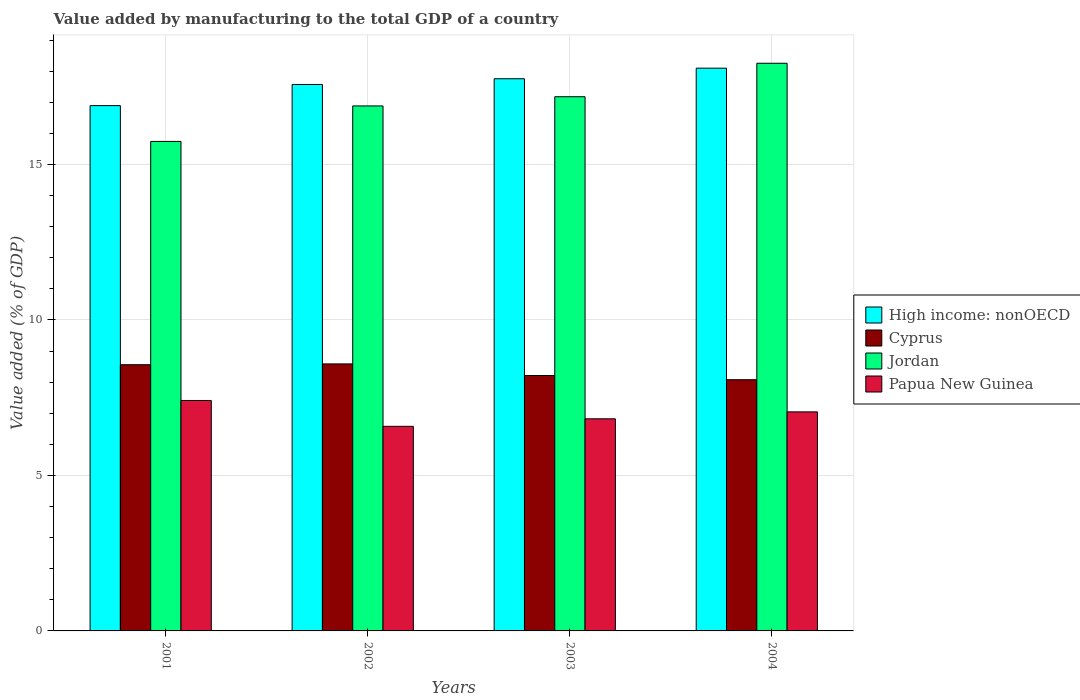How many groups of bars are there?
Your answer should be very brief. 4. Are the number of bars per tick equal to the number of legend labels?
Give a very brief answer. Yes. Are the number of bars on each tick of the X-axis equal?
Ensure brevity in your answer.  Yes. How many bars are there on the 4th tick from the left?
Provide a succinct answer. 4. How many bars are there on the 2nd tick from the right?
Your response must be concise. 4. What is the label of the 2nd group of bars from the left?
Your answer should be compact. 2002. What is the value added by manufacturing to the total GDP in Jordan in 2004?
Your answer should be very brief. 18.26. Across all years, what is the maximum value added by manufacturing to the total GDP in Cyprus?
Keep it short and to the point. 8.59. Across all years, what is the minimum value added by manufacturing to the total GDP in High income: nonOECD?
Your answer should be very brief. 16.9. In which year was the value added by manufacturing to the total GDP in High income: nonOECD maximum?
Offer a very short reply. 2004. In which year was the value added by manufacturing to the total GDP in Jordan minimum?
Provide a succinct answer. 2001. What is the total value added by manufacturing to the total GDP in Papua New Guinea in the graph?
Your answer should be very brief. 27.86. What is the difference between the value added by manufacturing to the total GDP in Papua New Guinea in 2002 and that in 2004?
Make the answer very short. -0.47. What is the difference between the value added by manufacturing to the total GDP in Papua New Guinea in 2001 and the value added by manufacturing to the total GDP in Jordan in 2002?
Make the answer very short. -9.47. What is the average value added by manufacturing to the total GDP in Jordan per year?
Provide a succinct answer. 17.02. In the year 2003, what is the difference between the value added by manufacturing to the total GDP in Papua New Guinea and value added by manufacturing to the total GDP in Jordan?
Your response must be concise. -10.36. What is the ratio of the value added by manufacturing to the total GDP in High income: nonOECD in 2001 to that in 2003?
Your answer should be compact. 0.95. Is the value added by manufacturing to the total GDP in High income: nonOECD in 2002 less than that in 2004?
Ensure brevity in your answer.  Yes. Is the difference between the value added by manufacturing to the total GDP in Papua New Guinea in 2002 and 2003 greater than the difference between the value added by manufacturing to the total GDP in Jordan in 2002 and 2003?
Provide a succinct answer. Yes. What is the difference between the highest and the second highest value added by manufacturing to the total GDP in Jordan?
Offer a very short reply. 1.08. What is the difference between the highest and the lowest value added by manufacturing to the total GDP in Papua New Guinea?
Make the answer very short. 0.83. Is the sum of the value added by manufacturing to the total GDP in Cyprus in 2002 and 2003 greater than the maximum value added by manufacturing to the total GDP in Papua New Guinea across all years?
Keep it short and to the point. Yes. What does the 1st bar from the left in 2004 represents?
Make the answer very short. High income: nonOECD. What does the 4th bar from the right in 2004 represents?
Ensure brevity in your answer.  High income: nonOECD. How many bars are there?
Your response must be concise. 16. What is the difference between two consecutive major ticks on the Y-axis?
Keep it short and to the point. 5. Does the graph contain any zero values?
Make the answer very short. No. Does the graph contain grids?
Give a very brief answer. Yes. Where does the legend appear in the graph?
Give a very brief answer. Center right. What is the title of the graph?
Make the answer very short. Value added by manufacturing to the total GDP of a country. Does "Venezuela" appear as one of the legend labels in the graph?
Give a very brief answer. No. What is the label or title of the X-axis?
Give a very brief answer. Years. What is the label or title of the Y-axis?
Offer a very short reply. Value added (% of GDP). What is the Value added (% of GDP) of High income: nonOECD in 2001?
Your answer should be compact. 16.9. What is the Value added (% of GDP) of Cyprus in 2001?
Your response must be concise. 8.56. What is the Value added (% of GDP) in Jordan in 2001?
Offer a very short reply. 15.74. What is the Value added (% of GDP) in Papua New Guinea in 2001?
Offer a terse response. 7.41. What is the Value added (% of GDP) of High income: nonOECD in 2002?
Offer a terse response. 17.58. What is the Value added (% of GDP) of Cyprus in 2002?
Keep it short and to the point. 8.59. What is the Value added (% of GDP) of Jordan in 2002?
Keep it short and to the point. 16.89. What is the Value added (% of GDP) of Papua New Guinea in 2002?
Your answer should be very brief. 6.58. What is the Value added (% of GDP) in High income: nonOECD in 2003?
Give a very brief answer. 17.76. What is the Value added (% of GDP) in Cyprus in 2003?
Your answer should be very brief. 8.21. What is the Value added (% of GDP) in Jordan in 2003?
Ensure brevity in your answer.  17.18. What is the Value added (% of GDP) of Papua New Guinea in 2003?
Your answer should be very brief. 6.82. What is the Value added (% of GDP) in High income: nonOECD in 2004?
Your answer should be compact. 18.1. What is the Value added (% of GDP) of Cyprus in 2004?
Provide a short and direct response. 8.08. What is the Value added (% of GDP) in Jordan in 2004?
Give a very brief answer. 18.26. What is the Value added (% of GDP) in Papua New Guinea in 2004?
Keep it short and to the point. 7.05. Across all years, what is the maximum Value added (% of GDP) in High income: nonOECD?
Your answer should be very brief. 18.1. Across all years, what is the maximum Value added (% of GDP) of Cyprus?
Give a very brief answer. 8.59. Across all years, what is the maximum Value added (% of GDP) in Jordan?
Provide a short and direct response. 18.26. Across all years, what is the maximum Value added (% of GDP) of Papua New Guinea?
Provide a succinct answer. 7.41. Across all years, what is the minimum Value added (% of GDP) in High income: nonOECD?
Provide a succinct answer. 16.9. Across all years, what is the minimum Value added (% of GDP) of Cyprus?
Provide a succinct answer. 8.08. Across all years, what is the minimum Value added (% of GDP) of Jordan?
Give a very brief answer. 15.74. Across all years, what is the minimum Value added (% of GDP) in Papua New Guinea?
Your answer should be compact. 6.58. What is the total Value added (% of GDP) of High income: nonOECD in the graph?
Your answer should be compact. 70.33. What is the total Value added (% of GDP) in Cyprus in the graph?
Ensure brevity in your answer.  33.44. What is the total Value added (% of GDP) of Jordan in the graph?
Offer a terse response. 68.07. What is the total Value added (% of GDP) of Papua New Guinea in the graph?
Your answer should be very brief. 27.86. What is the difference between the Value added (% of GDP) in High income: nonOECD in 2001 and that in 2002?
Give a very brief answer. -0.68. What is the difference between the Value added (% of GDP) of Cyprus in 2001 and that in 2002?
Your answer should be very brief. -0.03. What is the difference between the Value added (% of GDP) of Jordan in 2001 and that in 2002?
Offer a very short reply. -1.14. What is the difference between the Value added (% of GDP) of Papua New Guinea in 2001 and that in 2002?
Provide a short and direct response. 0.83. What is the difference between the Value added (% of GDP) in High income: nonOECD in 2001 and that in 2003?
Offer a very short reply. -0.86. What is the difference between the Value added (% of GDP) in Cyprus in 2001 and that in 2003?
Provide a succinct answer. 0.35. What is the difference between the Value added (% of GDP) of Jordan in 2001 and that in 2003?
Your answer should be compact. -1.44. What is the difference between the Value added (% of GDP) of Papua New Guinea in 2001 and that in 2003?
Offer a terse response. 0.59. What is the difference between the Value added (% of GDP) of High income: nonOECD in 2001 and that in 2004?
Ensure brevity in your answer.  -1.2. What is the difference between the Value added (% of GDP) in Cyprus in 2001 and that in 2004?
Provide a short and direct response. 0.48. What is the difference between the Value added (% of GDP) in Jordan in 2001 and that in 2004?
Your answer should be very brief. -2.51. What is the difference between the Value added (% of GDP) of Papua New Guinea in 2001 and that in 2004?
Give a very brief answer. 0.37. What is the difference between the Value added (% of GDP) of High income: nonOECD in 2002 and that in 2003?
Ensure brevity in your answer.  -0.18. What is the difference between the Value added (% of GDP) of Cyprus in 2002 and that in 2003?
Ensure brevity in your answer.  0.37. What is the difference between the Value added (% of GDP) of Jordan in 2002 and that in 2003?
Your answer should be very brief. -0.3. What is the difference between the Value added (% of GDP) in Papua New Guinea in 2002 and that in 2003?
Give a very brief answer. -0.24. What is the difference between the Value added (% of GDP) of High income: nonOECD in 2002 and that in 2004?
Give a very brief answer. -0.52. What is the difference between the Value added (% of GDP) in Cyprus in 2002 and that in 2004?
Your response must be concise. 0.51. What is the difference between the Value added (% of GDP) in Jordan in 2002 and that in 2004?
Your answer should be compact. -1.37. What is the difference between the Value added (% of GDP) in Papua New Guinea in 2002 and that in 2004?
Your answer should be compact. -0.47. What is the difference between the Value added (% of GDP) in High income: nonOECD in 2003 and that in 2004?
Offer a very short reply. -0.34. What is the difference between the Value added (% of GDP) of Cyprus in 2003 and that in 2004?
Offer a terse response. 0.14. What is the difference between the Value added (% of GDP) of Jordan in 2003 and that in 2004?
Provide a short and direct response. -1.08. What is the difference between the Value added (% of GDP) of Papua New Guinea in 2003 and that in 2004?
Offer a terse response. -0.22. What is the difference between the Value added (% of GDP) of High income: nonOECD in 2001 and the Value added (% of GDP) of Cyprus in 2002?
Ensure brevity in your answer.  8.31. What is the difference between the Value added (% of GDP) in High income: nonOECD in 2001 and the Value added (% of GDP) in Jordan in 2002?
Give a very brief answer. 0.01. What is the difference between the Value added (% of GDP) of High income: nonOECD in 2001 and the Value added (% of GDP) of Papua New Guinea in 2002?
Offer a very short reply. 10.31. What is the difference between the Value added (% of GDP) of Cyprus in 2001 and the Value added (% of GDP) of Jordan in 2002?
Provide a short and direct response. -8.32. What is the difference between the Value added (% of GDP) of Cyprus in 2001 and the Value added (% of GDP) of Papua New Guinea in 2002?
Give a very brief answer. 1.98. What is the difference between the Value added (% of GDP) of Jordan in 2001 and the Value added (% of GDP) of Papua New Guinea in 2002?
Your answer should be compact. 9.16. What is the difference between the Value added (% of GDP) in High income: nonOECD in 2001 and the Value added (% of GDP) in Cyprus in 2003?
Your response must be concise. 8.68. What is the difference between the Value added (% of GDP) of High income: nonOECD in 2001 and the Value added (% of GDP) of Jordan in 2003?
Provide a succinct answer. -0.29. What is the difference between the Value added (% of GDP) of High income: nonOECD in 2001 and the Value added (% of GDP) of Papua New Guinea in 2003?
Provide a succinct answer. 10.07. What is the difference between the Value added (% of GDP) in Cyprus in 2001 and the Value added (% of GDP) in Jordan in 2003?
Provide a short and direct response. -8.62. What is the difference between the Value added (% of GDP) in Cyprus in 2001 and the Value added (% of GDP) in Papua New Guinea in 2003?
Your response must be concise. 1.74. What is the difference between the Value added (% of GDP) in Jordan in 2001 and the Value added (% of GDP) in Papua New Guinea in 2003?
Your response must be concise. 8.92. What is the difference between the Value added (% of GDP) in High income: nonOECD in 2001 and the Value added (% of GDP) in Cyprus in 2004?
Offer a terse response. 8.82. What is the difference between the Value added (% of GDP) in High income: nonOECD in 2001 and the Value added (% of GDP) in Jordan in 2004?
Provide a short and direct response. -1.36. What is the difference between the Value added (% of GDP) of High income: nonOECD in 2001 and the Value added (% of GDP) of Papua New Guinea in 2004?
Make the answer very short. 9.85. What is the difference between the Value added (% of GDP) in Cyprus in 2001 and the Value added (% of GDP) in Jordan in 2004?
Offer a terse response. -9.7. What is the difference between the Value added (% of GDP) in Cyprus in 2001 and the Value added (% of GDP) in Papua New Guinea in 2004?
Provide a succinct answer. 1.52. What is the difference between the Value added (% of GDP) in Jordan in 2001 and the Value added (% of GDP) in Papua New Guinea in 2004?
Make the answer very short. 8.7. What is the difference between the Value added (% of GDP) of High income: nonOECD in 2002 and the Value added (% of GDP) of Cyprus in 2003?
Make the answer very short. 9.36. What is the difference between the Value added (% of GDP) of High income: nonOECD in 2002 and the Value added (% of GDP) of Jordan in 2003?
Your response must be concise. 0.39. What is the difference between the Value added (% of GDP) in High income: nonOECD in 2002 and the Value added (% of GDP) in Papua New Guinea in 2003?
Ensure brevity in your answer.  10.75. What is the difference between the Value added (% of GDP) in Cyprus in 2002 and the Value added (% of GDP) in Jordan in 2003?
Provide a short and direct response. -8.59. What is the difference between the Value added (% of GDP) of Cyprus in 2002 and the Value added (% of GDP) of Papua New Guinea in 2003?
Keep it short and to the point. 1.77. What is the difference between the Value added (% of GDP) in Jordan in 2002 and the Value added (% of GDP) in Papua New Guinea in 2003?
Make the answer very short. 10.06. What is the difference between the Value added (% of GDP) of High income: nonOECD in 2002 and the Value added (% of GDP) of Cyprus in 2004?
Give a very brief answer. 9.5. What is the difference between the Value added (% of GDP) of High income: nonOECD in 2002 and the Value added (% of GDP) of Jordan in 2004?
Your response must be concise. -0.68. What is the difference between the Value added (% of GDP) in High income: nonOECD in 2002 and the Value added (% of GDP) in Papua New Guinea in 2004?
Ensure brevity in your answer.  10.53. What is the difference between the Value added (% of GDP) in Cyprus in 2002 and the Value added (% of GDP) in Jordan in 2004?
Provide a short and direct response. -9.67. What is the difference between the Value added (% of GDP) in Cyprus in 2002 and the Value added (% of GDP) in Papua New Guinea in 2004?
Provide a succinct answer. 1.54. What is the difference between the Value added (% of GDP) in Jordan in 2002 and the Value added (% of GDP) in Papua New Guinea in 2004?
Keep it short and to the point. 9.84. What is the difference between the Value added (% of GDP) of High income: nonOECD in 2003 and the Value added (% of GDP) of Cyprus in 2004?
Your answer should be compact. 9.68. What is the difference between the Value added (% of GDP) in High income: nonOECD in 2003 and the Value added (% of GDP) in Jordan in 2004?
Your response must be concise. -0.5. What is the difference between the Value added (% of GDP) in High income: nonOECD in 2003 and the Value added (% of GDP) in Papua New Guinea in 2004?
Offer a terse response. 10.71. What is the difference between the Value added (% of GDP) in Cyprus in 2003 and the Value added (% of GDP) in Jordan in 2004?
Offer a very short reply. -10.04. What is the difference between the Value added (% of GDP) in Cyprus in 2003 and the Value added (% of GDP) in Papua New Guinea in 2004?
Offer a very short reply. 1.17. What is the difference between the Value added (% of GDP) in Jordan in 2003 and the Value added (% of GDP) in Papua New Guinea in 2004?
Your answer should be very brief. 10.14. What is the average Value added (% of GDP) in High income: nonOECD per year?
Offer a very short reply. 17.58. What is the average Value added (% of GDP) in Cyprus per year?
Provide a succinct answer. 8.36. What is the average Value added (% of GDP) of Jordan per year?
Provide a succinct answer. 17.02. What is the average Value added (% of GDP) in Papua New Guinea per year?
Your response must be concise. 6.96. In the year 2001, what is the difference between the Value added (% of GDP) in High income: nonOECD and Value added (% of GDP) in Cyprus?
Your answer should be compact. 8.33. In the year 2001, what is the difference between the Value added (% of GDP) in High income: nonOECD and Value added (% of GDP) in Jordan?
Your response must be concise. 1.15. In the year 2001, what is the difference between the Value added (% of GDP) of High income: nonOECD and Value added (% of GDP) of Papua New Guinea?
Offer a terse response. 9.48. In the year 2001, what is the difference between the Value added (% of GDP) in Cyprus and Value added (% of GDP) in Jordan?
Your response must be concise. -7.18. In the year 2001, what is the difference between the Value added (% of GDP) in Cyprus and Value added (% of GDP) in Papua New Guinea?
Your response must be concise. 1.15. In the year 2001, what is the difference between the Value added (% of GDP) of Jordan and Value added (% of GDP) of Papua New Guinea?
Give a very brief answer. 8.33. In the year 2002, what is the difference between the Value added (% of GDP) in High income: nonOECD and Value added (% of GDP) in Cyprus?
Offer a terse response. 8.99. In the year 2002, what is the difference between the Value added (% of GDP) of High income: nonOECD and Value added (% of GDP) of Jordan?
Give a very brief answer. 0.69. In the year 2002, what is the difference between the Value added (% of GDP) of High income: nonOECD and Value added (% of GDP) of Papua New Guinea?
Provide a short and direct response. 11. In the year 2002, what is the difference between the Value added (% of GDP) of Cyprus and Value added (% of GDP) of Jordan?
Your answer should be compact. -8.3. In the year 2002, what is the difference between the Value added (% of GDP) of Cyprus and Value added (% of GDP) of Papua New Guinea?
Give a very brief answer. 2.01. In the year 2002, what is the difference between the Value added (% of GDP) in Jordan and Value added (% of GDP) in Papua New Guinea?
Offer a terse response. 10.31. In the year 2003, what is the difference between the Value added (% of GDP) in High income: nonOECD and Value added (% of GDP) in Cyprus?
Keep it short and to the point. 9.54. In the year 2003, what is the difference between the Value added (% of GDP) of High income: nonOECD and Value added (% of GDP) of Jordan?
Offer a very short reply. 0.58. In the year 2003, what is the difference between the Value added (% of GDP) of High income: nonOECD and Value added (% of GDP) of Papua New Guinea?
Ensure brevity in your answer.  10.94. In the year 2003, what is the difference between the Value added (% of GDP) in Cyprus and Value added (% of GDP) in Jordan?
Make the answer very short. -8.97. In the year 2003, what is the difference between the Value added (% of GDP) in Cyprus and Value added (% of GDP) in Papua New Guinea?
Ensure brevity in your answer.  1.39. In the year 2003, what is the difference between the Value added (% of GDP) of Jordan and Value added (% of GDP) of Papua New Guinea?
Make the answer very short. 10.36. In the year 2004, what is the difference between the Value added (% of GDP) of High income: nonOECD and Value added (% of GDP) of Cyprus?
Your answer should be very brief. 10.02. In the year 2004, what is the difference between the Value added (% of GDP) of High income: nonOECD and Value added (% of GDP) of Jordan?
Your response must be concise. -0.16. In the year 2004, what is the difference between the Value added (% of GDP) of High income: nonOECD and Value added (% of GDP) of Papua New Guinea?
Give a very brief answer. 11.05. In the year 2004, what is the difference between the Value added (% of GDP) in Cyprus and Value added (% of GDP) in Jordan?
Offer a terse response. -10.18. In the year 2004, what is the difference between the Value added (% of GDP) in Cyprus and Value added (% of GDP) in Papua New Guinea?
Give a very brief answer. 1.03. In the year 2004, what is the difference between the Value added (% of GDP) in Jordan and Value added (% of GDP) in Papua New Guinea?
Make the answer very short. 11.21. What is the ratio of the Value added (% of GDP) in High income: nonOECD in 2001 to that in 2002?
Offer a very short reply. 0.96. What is the ratio of the Value added (% of GDP) of Jordan in 2001 to that in 2002?
Offer a very short reply. 0.93. What is the ratio of the Value added (% of GDP) in Papua New Guinea in 2001 to that in 2002?
Provide a succinct answer. 1.13. What is the ratio of the Value added (% of GDP) in High income: nonOECD in 2001 to that in 2003?
Ensure brevity in your answer.  0.95. What is the ratio of the Value added (% of GDP) in Cyprus in 2001 to that in 2003?
Your answer should be compact. 1.04. What is the ratio of the Value added (% of GDP) of Jordan in 2001 to that in 2003?
Your response must be concise. 0.92. What is the ratio of the Value added (% of GDP) in Papua New Guinea in 2001 to that in 2003?
Your response must be concise. 1.09. What is the ratio of the Value added (% of GDP) in High income: nonOECD in 2001 to that in 2004?
Ensure brevity in your answer.  0.93. What is the ratio of the Value added (% of GDP) in Cyprus in 2001 to that in 2004?
Make the answer very short. 1.06. What is the ratio of the Value added (% of GDP) in Jordan in 2001 to that in 2004?
Ensure brevity in your answer.  0.86. What is the ratio of the Value added (% of GDP) in Papua New Guinea in 2001 to that in 2004?
Offer a terse response. 1.05. What is the ratio of the Value added (% of GDP) of High income: nonOECD in 2002 to that in 2003?
Make the answer very short. 0.99. What is the ratio of the Value added (% of GDP) in Cyprus in 2002 to that in 2003?
Ensure brevity in your answer.  1.05. What is the ratio of the Value added (% of GDP) in Jordan in 2002 to that in 2003?
Give a very brief answer. 0.98. What is the ratio of the Value added (% of GDP) of Papua New Guinea in 2002 to that in 2003?
Offer a very short reply. 0.96. What is the ratio of the Value added (% of GDP) of Cyprus in 2002 to that in 2004?
Ensure brevity in your answer.  1.06. What is the ratio of the Value added (% of GDP) of Jordan in 2002 to that in 2004?
Give a very brief answer. 0.92. What is the ratio of the Value added (% of GDP) in Papua New Guinea in 2002 to that in 2004?
Your response must be concise. 0.93. What is the ratio of the Value added (% of GDP) in High income: nonOECD in 2003 to that in 2004?
Make the answer very short. 0.98. What is the ratio of the Value added (% of GDP) of Cyprus in 2003 to that in 2004?
Your response must be concise. 1.02. What is the ratio of the Value added (% of GDP) of Jordan in 2003 to that in 2004?
Ensure brevity in your answer.  0.94. What is the ratio of the Value added (% of GDP) of Papua New Guinea in 2003 to that in 2004?
Offer a terse response. 0.97. What is the difference between the highest and the second highest Value added (% of GDP) in High income: nonOECD?
Keep it short and to the point. 0.34. What is the difference between the highest and the second highest Value added (% of GDP) in Cyprus?
Provide a succinct answer. 0.03. What is the difference between the highest and the second highest Value added (% of GDP) of Jordan?
Your response must be concise. 1.08. What is the difference between the highest and the second highest Value added (% of GDP) of Papua New Guinea?
Keep it short and to the point. 0.37. What is the difference between the highest and the lowest Value added (% of GDP) of High income: nonOECD?
Offer a very short reply. 1.2. What is the difference between the highest and the lowest Value added (% of GDP) in Cyprus?
Your response must be concise. 0.51. What is the difference between the highest and the lowest Value added (% of GDP) of Jordan?
Ensure brevity in your answer.  2.51. What is the difference between the highest and the lowest Value added (% of GDP) in Papua New Guinea?
Ensure brevity in your answer.  0.83. 